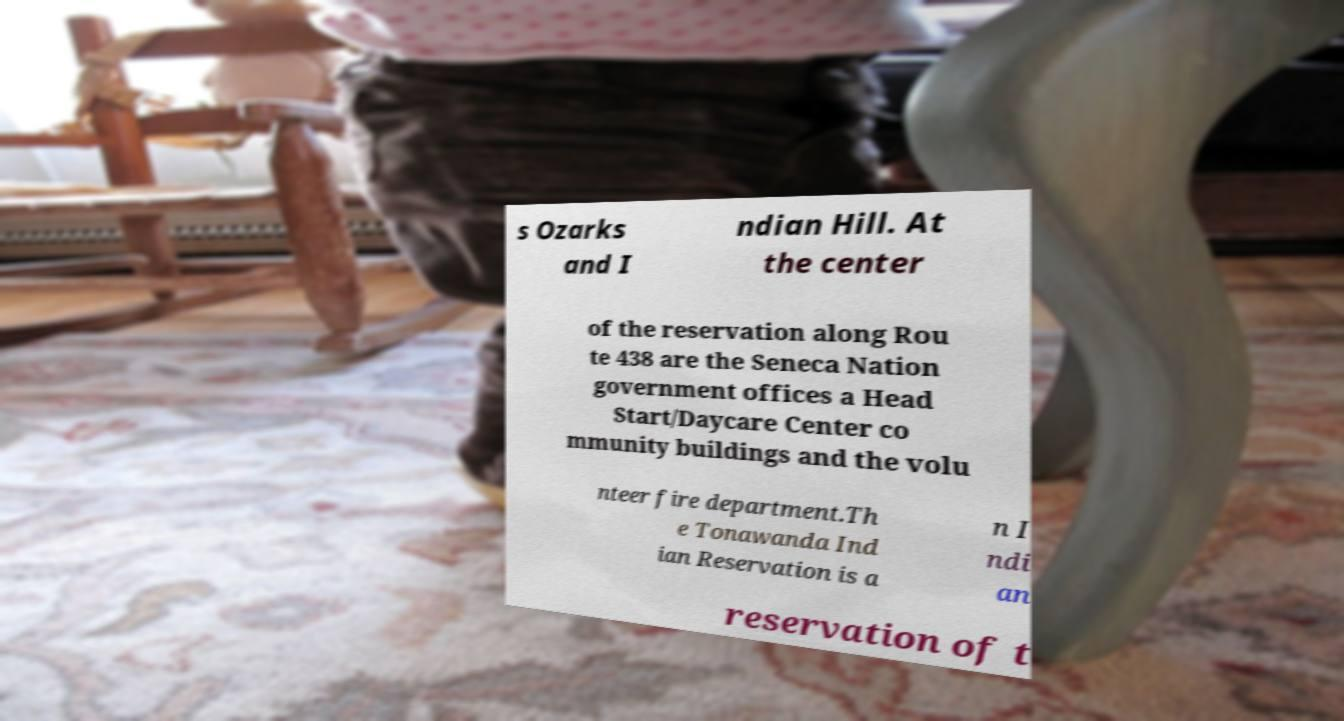Can you accurately transcribe the text from the provided image for me? s Ozarks and I ndian Hill. At the center of the reservation along Rou te 438 are the Seneca Nation government offices a Head Start/Daycare Center co mmunity buildings and the volu nteer fire department.Th e Tonawanda Ind ian Reservation is a n I ndi an reservation of t 